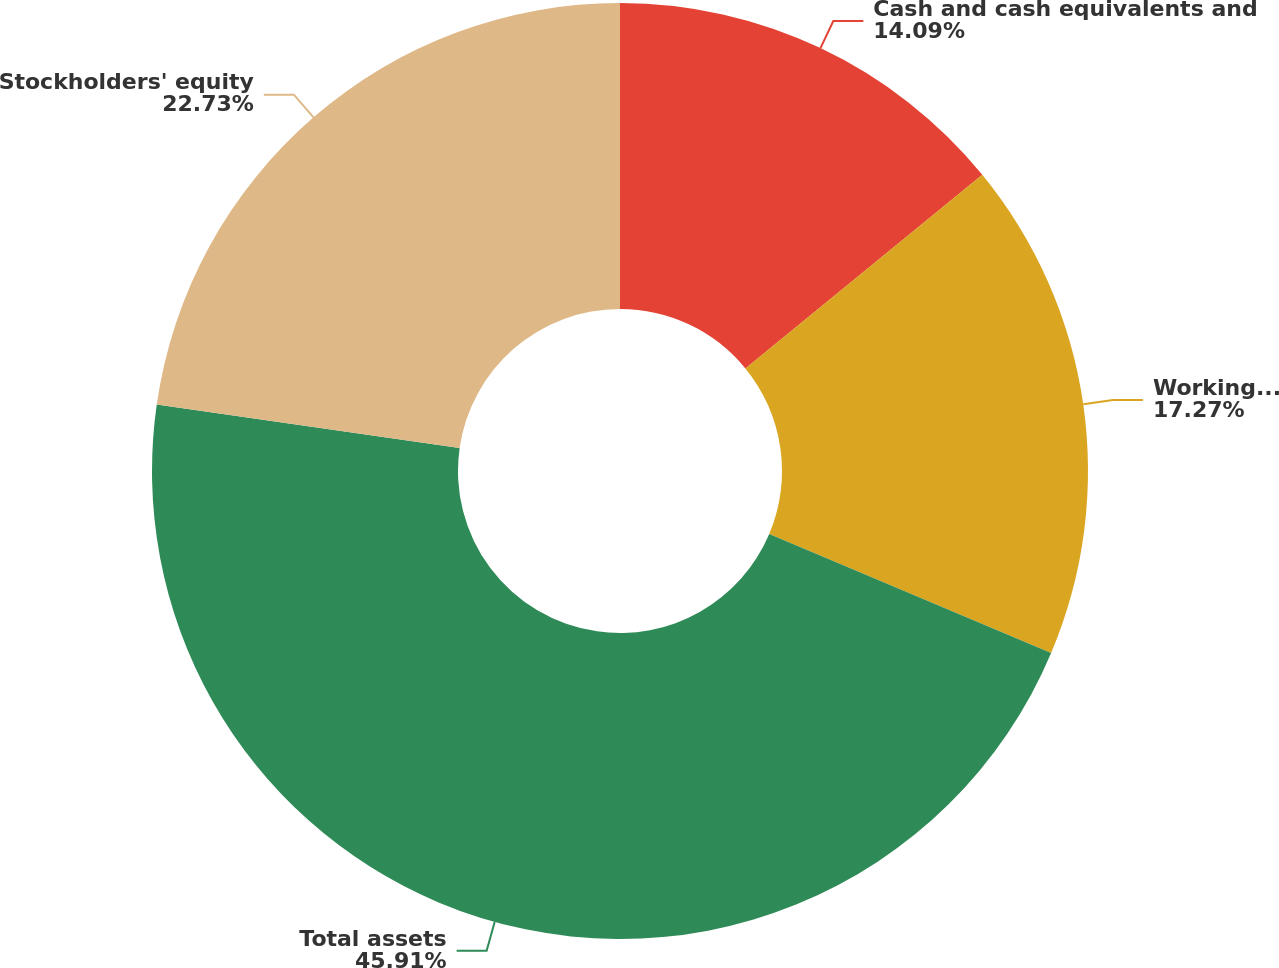Convert chart. <chart><loc_0><loc_0><loc_500><loc_500><pie_chart><fcel>Cash and cash equivalents and<fcel>Working capital<fcel>Total assets<fcel>Stockholders' equity<nl><fcel>14.09%<fcel>17.27%<fcel>45.91%<fcel>22.73%<nl></chart> 